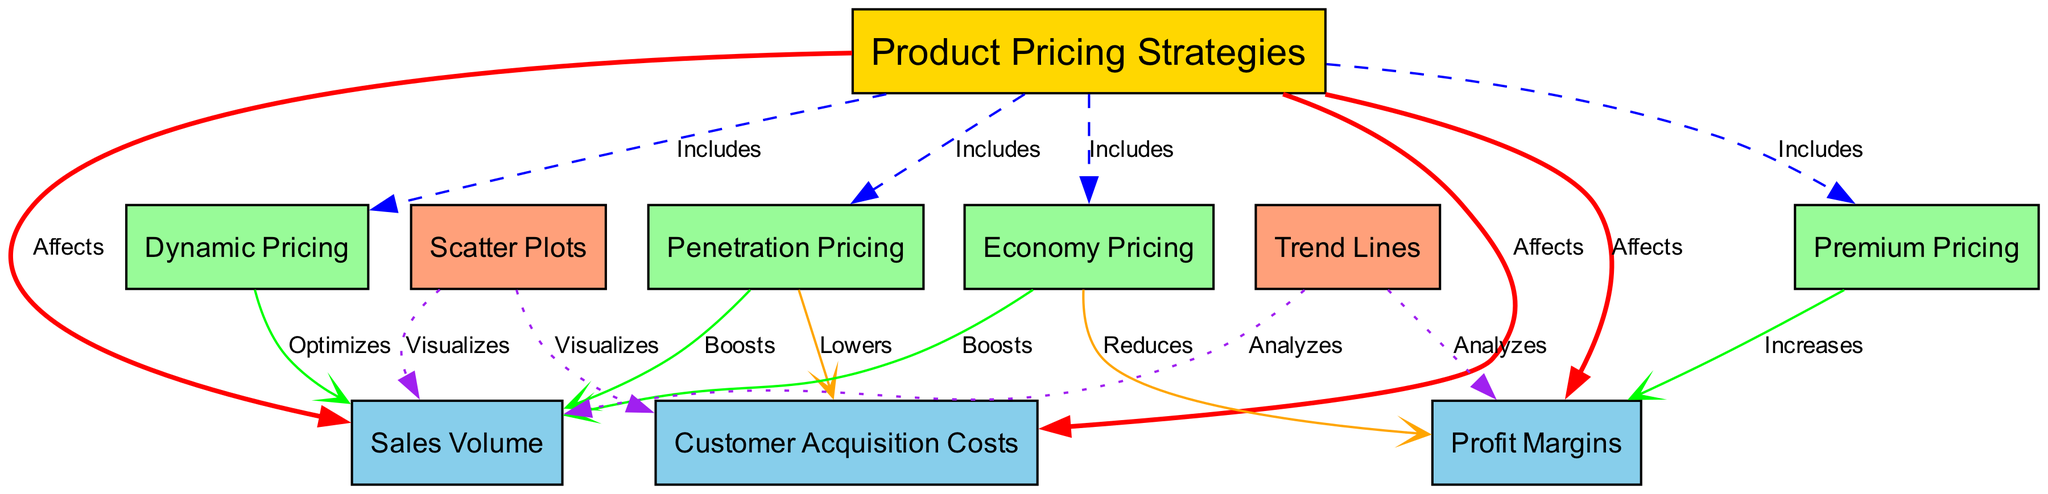What are the four product pricing strategies included in the diagram? The diagram lists four pricing strategies connected to the "Product Pricing Strategies" node: Premium Pricing, Penetration Pricing, Economy Pricing, and Dynamic Pricing.
Answer: Premium Pricing, Penetration Pricing, Economy Pricing, Dynamic Pricing How many edges are there in the diagram? By counting the connections (edges) between nodes, we find a total of 19 edges.
Answer: 19 What is the effect of penetration pricing on customer acquisition costs? The diagram indicates that Penetration Pricing lowers customer acquisition costs, thus showing a direct negative effect.
Answer: Lowers How does dynamic pricing affect sales volume? The edge connecting Dynamic Pricing to Sales Volume states that it optimizes sales volume, indicating a positive adjustment based on this strategy.
Answer: Optimizes What color represents the nodes for sales volume, profit margins, and customer acquisition costs? In the diagram, the nodes for Sales Volume, Profit Margins, and Customer Acquisition Costs are colored #87CEEB, which is a light blue.
Answer: Light blue Which pricing strategy is said to increase profit margins? The diagram shows an edge from Premium Pricing to Profit Margins that specifically states it increases profit margins.
Answer: Increases How does economy pricing affect sales volume compared to profit margins? The diagram shows that Economy Pricing boosts sales volume but reduces profit margins, creating a trade-off between the two outcomes.
Answer: Boosts sales volume, Reduces profit margins What do trend lines analyze in this diagram? The trend lines analyze both sales volume and profit margins, as shown by the two edges originating from the trend lines node.
Answer: Sales volume, Profit margins What visual element does the scatter plot represent in relation to customer acquisition costs? The scatter plot visualizes customer acquisition costs alongside sales volume, providing a visual interpretation of their relationship.
Answer: Visualizes 